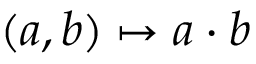Convert formula to latex. <formula><loc_0><loc_0><loc_500><loc_500>( a , b ) \mapsto a \cdot b</formula> 